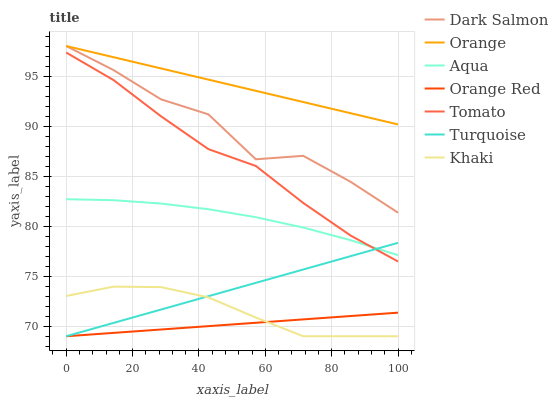Does Orange Red have the minimum area under the curve?
Answer yes or no. Yes. Does Orange have the maximum area under the curve?
Answer yes or no. Yes. Does Turquoise have the minimum area under the curve?
Answer yes or no. No. Does Turquoise have the maximum area under the curve?
Answer yes or no. No. Is Orange Red the smoothest?
Answer yes or no. Yes. Is Dark Salmon the roughest?
Answer yes or no. Yes. Is Turquoise the smoothest?
Answer yes or no. No. Is Turquoise the roughest?
Answer yes or no. No. Does Turquoise have the lowest value?
Answer yes or no. Yes. Does Aqua have the lowest value?
Answer yes or no. No. Does Orange have the highest value?
Answer yes or no. Yes. Does Turquoise have the highest value?
Answer yes or no. No. Is Orange Red less than Aqua?
Answer yes or no. Yes. Is Orange greater than Turquoise?
Answer yes or no. Yes. Does Dark Salmon intersect Orange?
Answer yes or no. Yes. Is Dark Salmon less than Orange?
Answer yes or no. No. Is Dark Salmon greater than Orange?
Answer yes or no. No. Does Orange Red intersect Aqua?
Answer yes or no. No. 